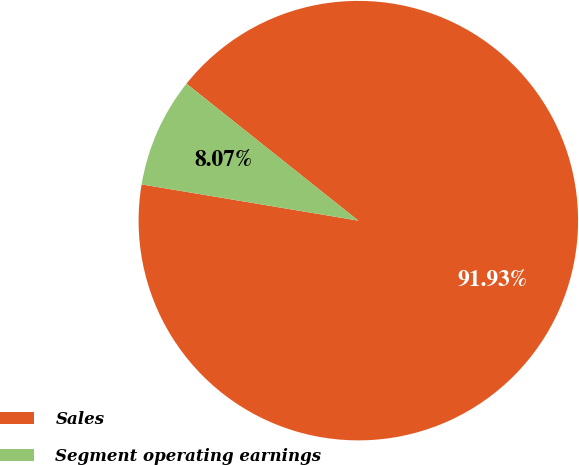Convert chart to OTSL. <chart><loc_0><loc_0><loc_500><loc_500><pie_chart><fcel>Sales<fcel>Segment operating earnings<nl><fcel>91.93%<fcel>8.07%<nl></chart> 